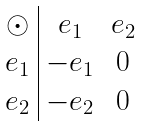<formula> <loc_0><loc_0><loc_500><loc_500>\begin{array} { c | c c } \odot & e _ { 1 } & e _ { 2 } \\ e _ { 1 } & - e _ { 1 } & 0 \\ e _ { 2 } & - e _ { 2 } & 0 \end{array}</formula> 